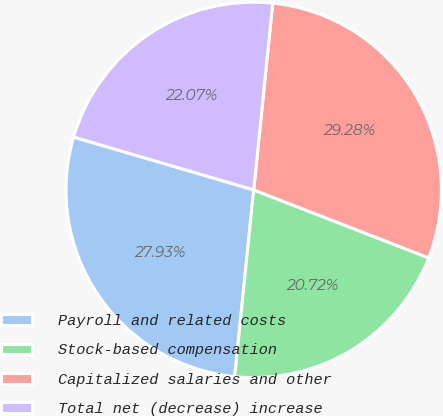<chart> <loc_0><loc_0><loc_500><loc_500><pie_chart><fcel>Payroll and related costs<fcel>Stock-based compensation<fcel>Capitalized salaries and other<fcel>Total net (decrease) increase<nl><fcel>27.93%<fcel>20.72%<fcel>29.28%<fcel>22.07%<nl></chart> 